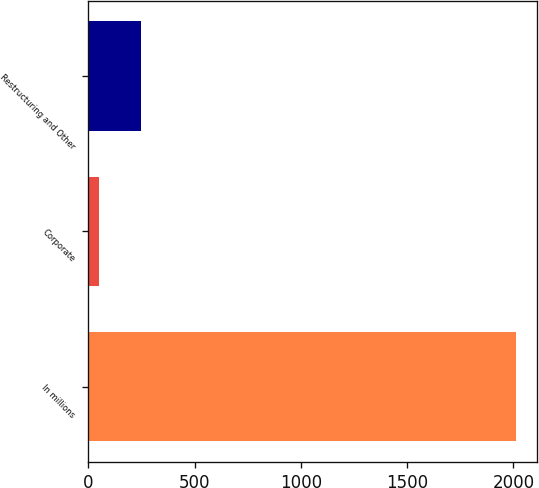<chart> <loc_0><loc_0><loc_500><loc_500><bar_chart><fcel>In millions<fcel>Corporate<fcel>Restructuring and Other<nl><fcel>2012<fcel>51<fcel>247.1<nl></chart> 